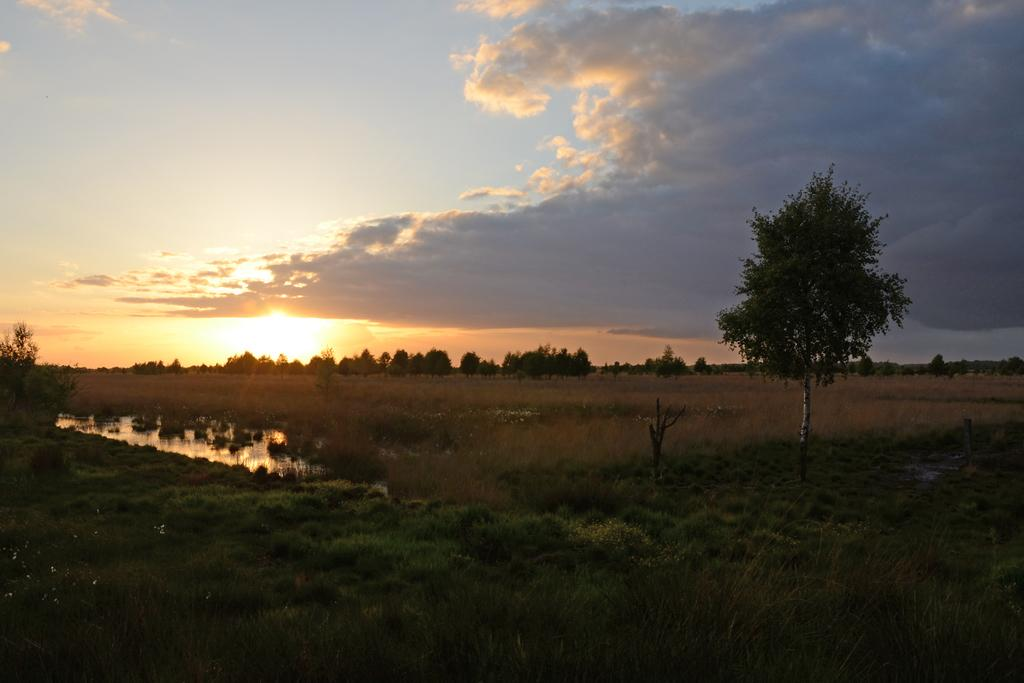What type of vegetation is present on the ground in the image? There is grass on the ground in the image. What is located in the front of the image? There is a tree in the front of the image. What can be seen in the background of the image? There are trees and dry grass in the background of the image. How would you describe the sky in the image? The sky is cloudy in the image. Where is the guide leading the boats in the image? There are no boats or guides present in the image. 